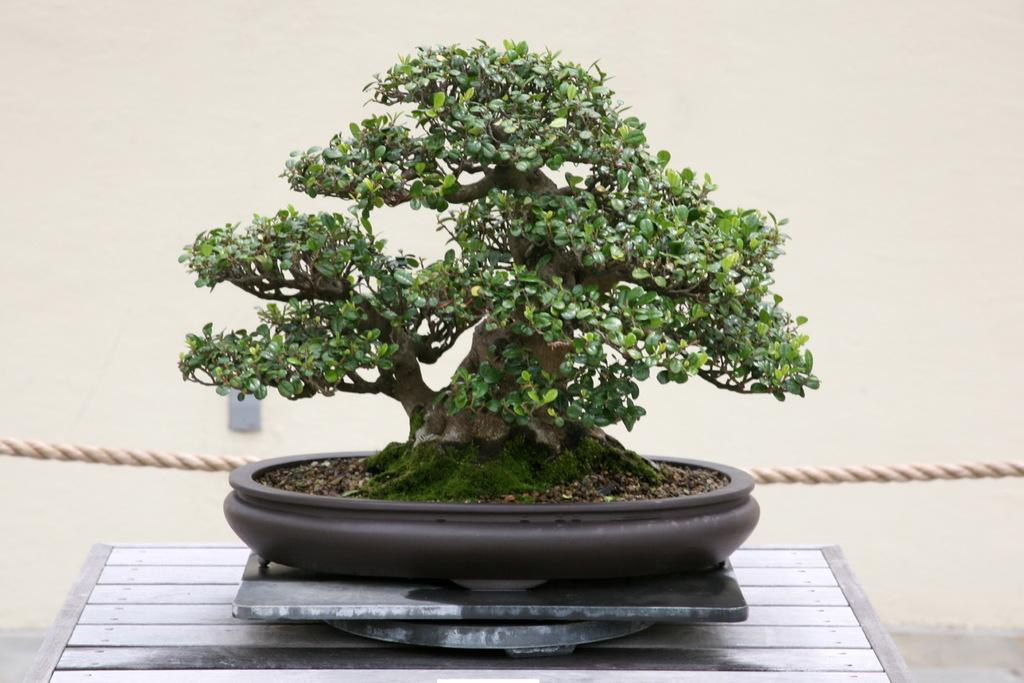What type of plant is in the image? There is a bonsai plant in the image. How is the bonsai plant contained? The bonsai plant is in a pot. What is the pot resting on in the image? The pot is on a metal surface. What can be seen in the background of the image? There is a rope and a wall visible in the background of the image. How does the jelly provide comfort to the kitten in the image? There is no jelly or kitten present in the image; it features a bonsai plant in a pot on a metal surface with a rope and a wall visible in the background. 